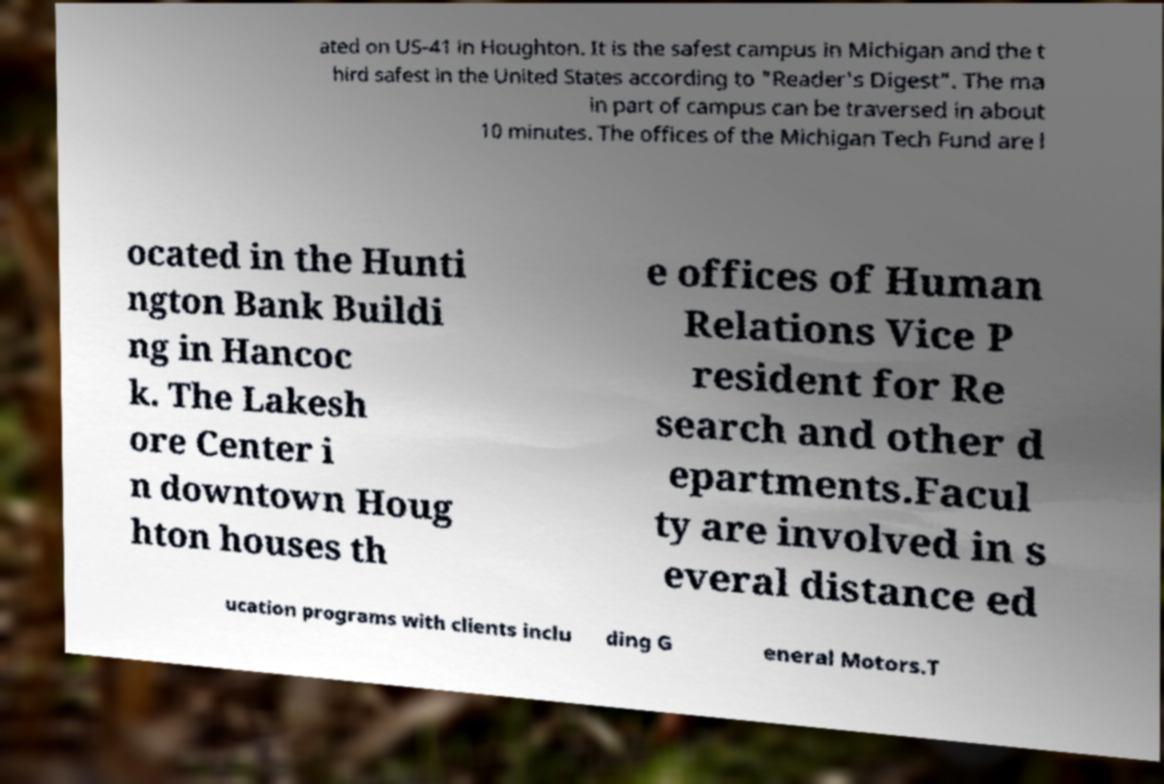Please read and relay the text visible in this image. What does it say? ated on US-41 in Houghton. It is the safest campus in Michigan and the t hird safest in the United States according to "Reader's Digest". The ma in part of campus can be traversed in about 10 minutes. The offices of the Michigan Tech Fund are l ocated in the Hunti ngton Bank Buildi ng in Hancoc k. The Lakesh ore Center i n downtown Houg hton houses th e offices of Human Relations Vice P resident for Re search and other d epartments.Facul ty are involved in s everal distance ed ucation programs with clients inclu ding G eneral Motors.T 